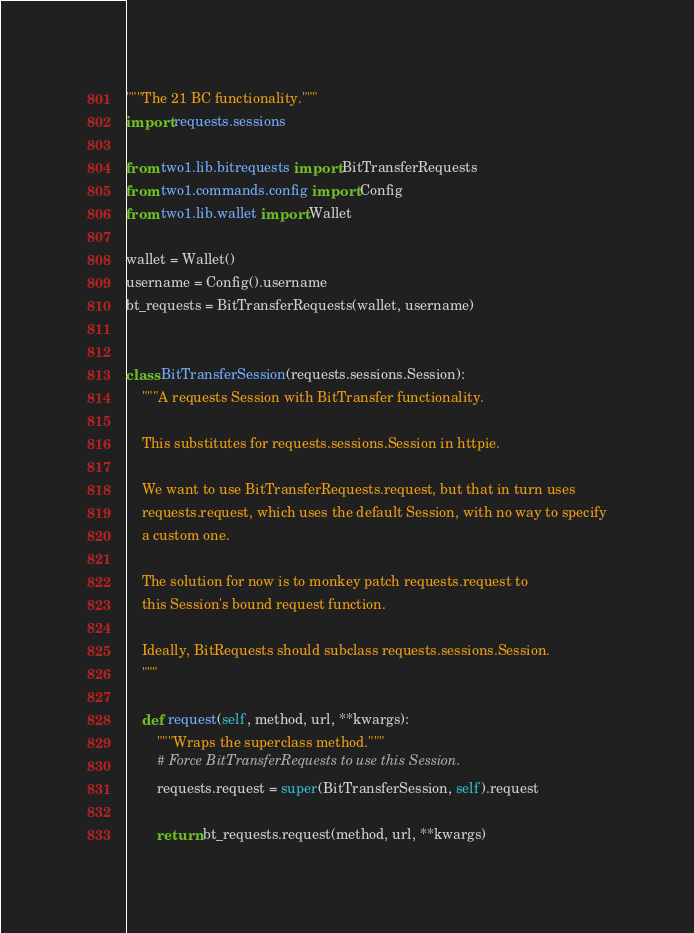Convert code to text. <code><loc_0><loc_0><loc_500><loc_500><_Python_>"""The 21 BC functionality."""
import requests.sessions

from two1.lib.bitrequests import BitTransferRequests
from two1.commands.config import Config
from two1.lib.wallet import Wallet

wallet = Wallet()
username = Config().username
bt_requests = BitTransferRequests(wallet, username)


class BitTransferSession(requests.sessions.Session):
    """A requests Session with BitTransfer functionality.

    This substitutes for requests.sessions.Session in httpie.

    We want to use BitTransferRequests.request, but that in turn uses
    requests.request, which uses the default Session, with no way to specify
    a custom one.

    The solution for now is to monkey patch requests.request to
    this Session's bound request function.

    Ideally, BitRequests should subclass requests.sessions.Session.
    """

    def request(self, method, url, **kwargs):
        """Wraps the superclass method."""
        # Force BitTransferRequests to use this Session.
        requests.request = super(BitTransferSession, self).request

        return bt_requests.request(method, url, **kwargs)
</code> 